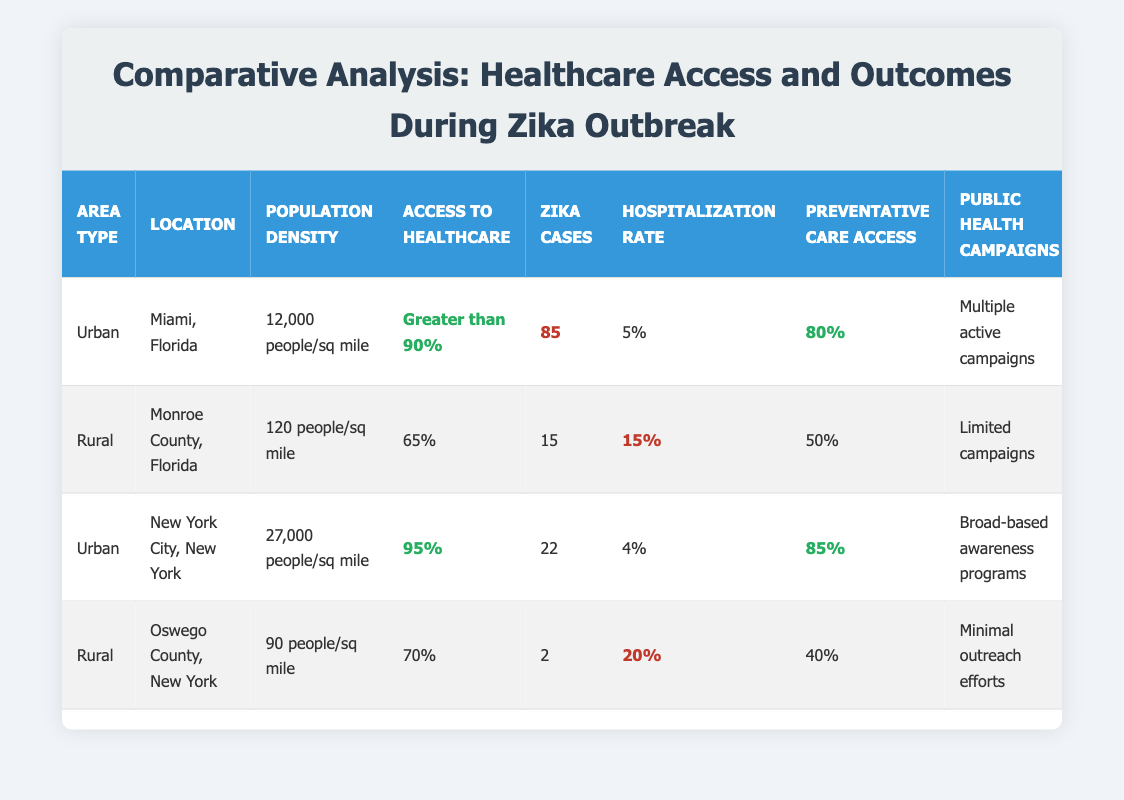What is the population density of New York City, New York? The table lists the population density for New York City as 27,000 people/sq mile directly under the Population Density column.
Answer: 27,000 people/sq mile In which area type was the highest number of Zika cases reported? By comparing the Zika Cases Reported column, Miami has the highest number of cases at 85, and it is listed under the Urban area type.
Answer: Urban What is the average hospitalization rate for Rural areas? The hospitalization rates for Rural areas are 15% (Monroe County) and 20% (Oswego County). The average is calculated as (15 + 20) / 2 = 17.5%.
Answer: 17.5% Does Monroe County have a higher access to healthcare than Miami? The access to healthcare for Monroe County is 65%, while Miami's access is greater than 90%. Since 65% is less than 90%, the statement is false.
Answer: No What is the difference in access to healthcare between Urban and Rural areas based on the highest values? The highest access to healthcare for Urban areas is 95% (New York City), while the highest for Rural areas is 70% (Oswego County). The difference is 95% - 70% = 25%.
Answer: 25% What percentage of Preventative Care Access is reported in Miami, Florida? According to the table, Miami, Florida has a Preventative Care Access listed as 80%. This is a direct retrieval from the table under the Preventative Care Access column for Miami.
Answer: 80% How many Zika cases were reported in total for all areas? To find the total Zika cases, we add the Zika cases reported: 85 (Miami) + 15 (Monroe County) + 22 (New York City) + 2 (Oswego County) = 124.
Answer: 124 Is there a public health campaign in Oswego County? The table shows "Minimal outreach efforts" under Public Health Campaigns for Oswego County, indicating that there is a public health campaign, albeit a minimal one. Therefore, the answer is true.
Answer: Yes How does the access to healthcare compare between Urban and Rural areas in this analysis? Urban areas have access to healthcare levels of over 90% (greater than 90% for Miami and 95% for New York City), while Rural areas are significantly lower at 65% for Monroe County and 70% for Oswego County. This clearly shows Urban areas have considerably better access.
Answer: Urban areas have better access 